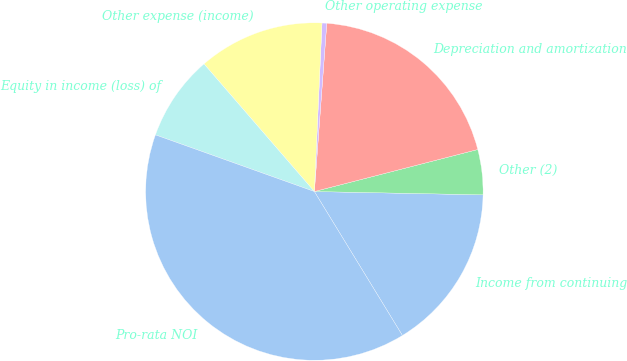Convert chart to OTSL. <chart><loc_0><loc_0><loc_500><loc_500><pie_chart><fcel>Income from continuing<fcel>Other (2)<fcel>Depreciation and amortization<fcel>Other operating expense<fcel>Other expense (income)<fcel>Equity in income (loss) of<fcel>Pro-rata NOI<nl><fcel>15.95%<fcel>4.32%<fcel>19.82%<fcel>0.45%<fcel>12.07%<fcel>8.2%<fcel>39.19%<nl></chart> 